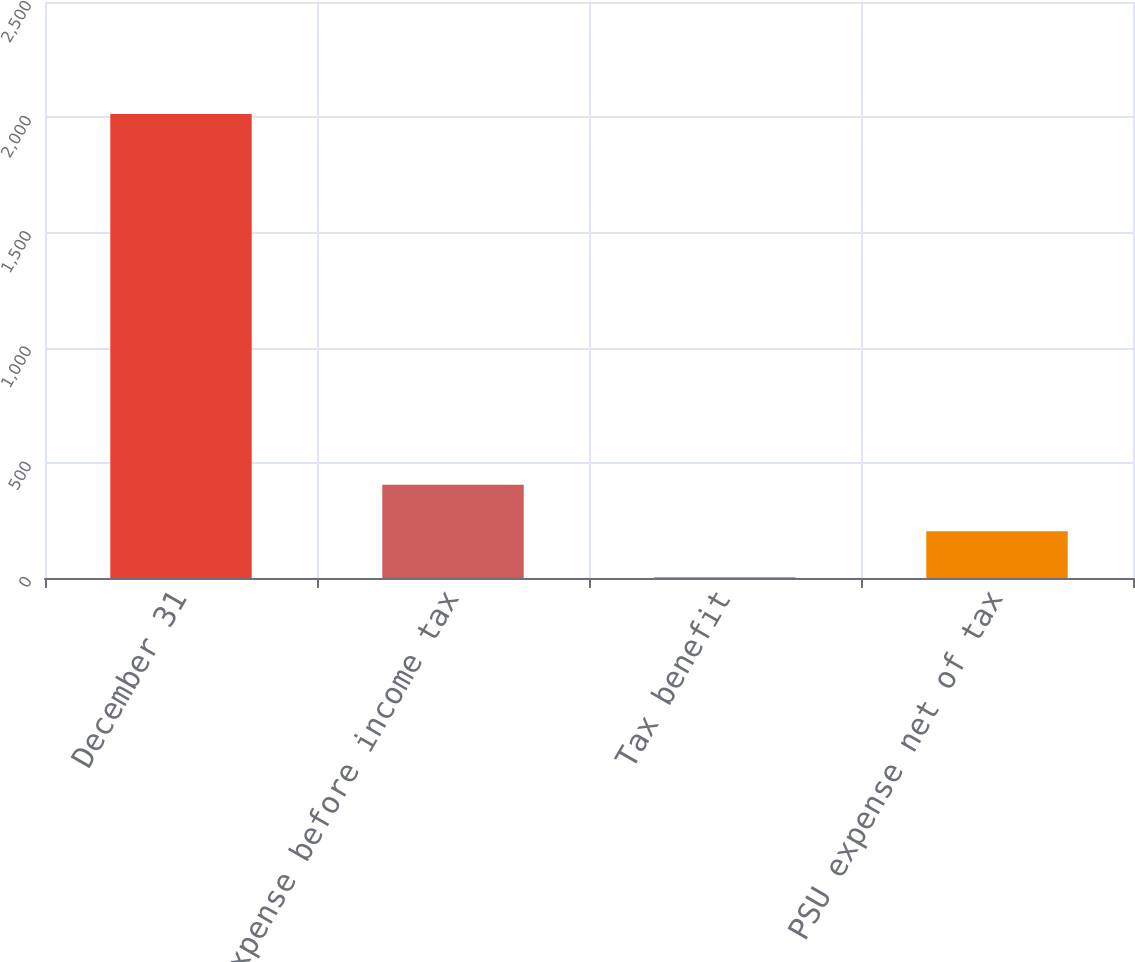Convert chart. <chart><loc_0><loc_0><loc_500><loc_500><bar_chart><fcel>December 31<fcel>PSU expense before income tax<fcel>Tax benefit<fcel>PSU expense net of tax<nl><fcel>2014<fcel>404.4<fcel>2<fcel>203.2<nl></chart> 